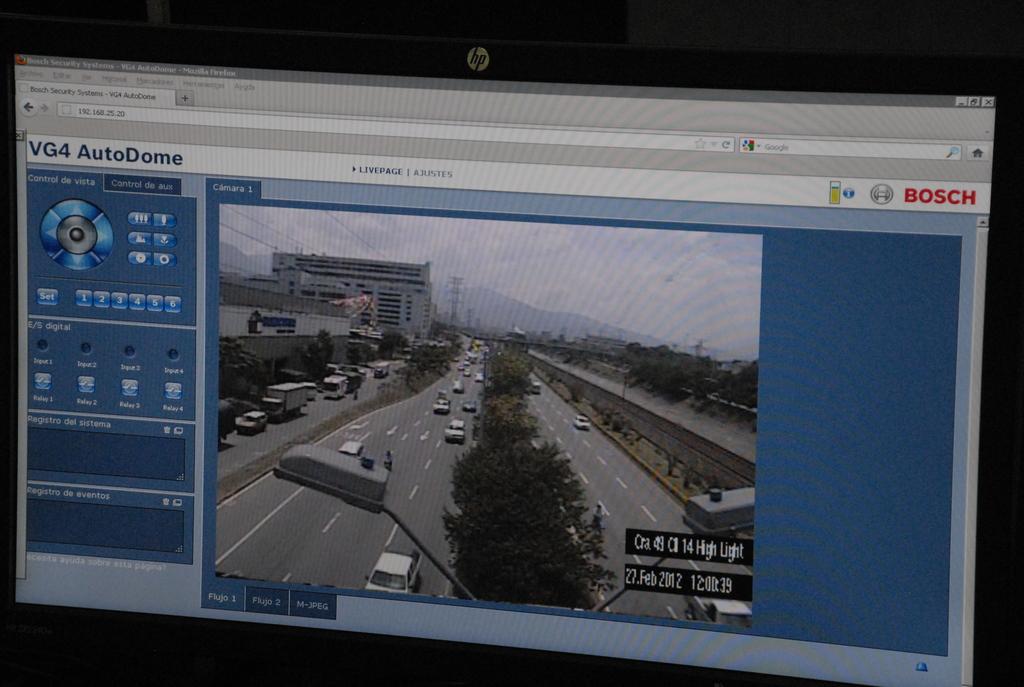What year was this footage shot?
Your answer should be compact. 2012. 